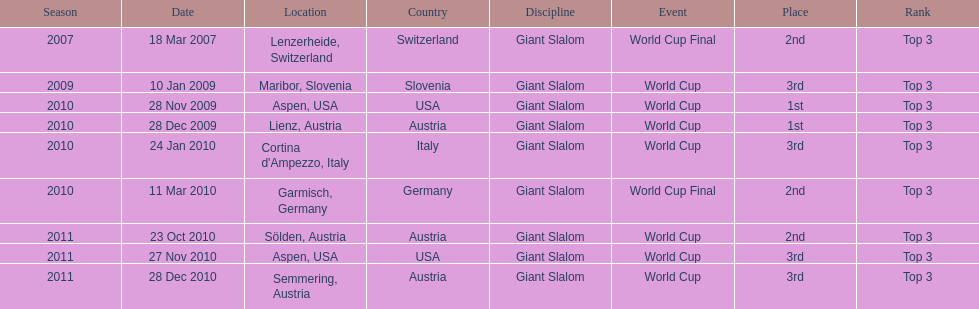What was the finishing place of the last race in december 2010? 3rd. I'm looking to parse the entire table for insights. Could you assist me with that? {'header': ['Season', 'Date', 'Location', 'Country', 'Discipline', 'Event', 'Place', 'Rank'], 'rows': [['2007', '18 Mar 2007', 'Lenzerheide, Switzerland', 'Switzerland', 'Giant Slalom', 'World Cup Final', '2nd', 'Top 3'], ['2009', '10 Jan 2009', 'Maribor, Slovenia', 'Slovenia', 'Giant Slalom', 'World Cup', '3rd', 'Top 3'], ['2010', '28 Nov 2009', 'Aspen, USA', 'USA', 'Giant Slalom', 'World Cup', '1st', 'Top 3'], ['2010', '28 Dec 2009', 'Lienz, Austria', 'Austria', 'Giant Slalom', 'World Cup', '1st', 'Top 3'], ['2010', '24 Jan 2010', "Cortina d'Ampezzo, Italy", 'Italy', 'Giant Slalom', 'World Cup', '3rd', 'Top 3'], ['2010', '11 Mar 2010', 'Garmisch, Germany', 'Germany', 'Giant Slalom', 'World Cup Final', '2nd', 'Top 3'], ['2011', '23 Oct 2010', 'Sölden, Austria', 'Austria', 'Giant Slalom', 'World Cup', '2nd', 'Top 3'], ['2011', '27 Nov 2010', 'Aspen, USA', 'USA', 'Giant Slalom', 'World Cup', '3rd', 'Top 3'], ['2011', '28 Dec 2010', 'Semmering, Austria', 'Austria', 'Giant Slalom', 'World Cup', '3rd', 'Top 3']]} 